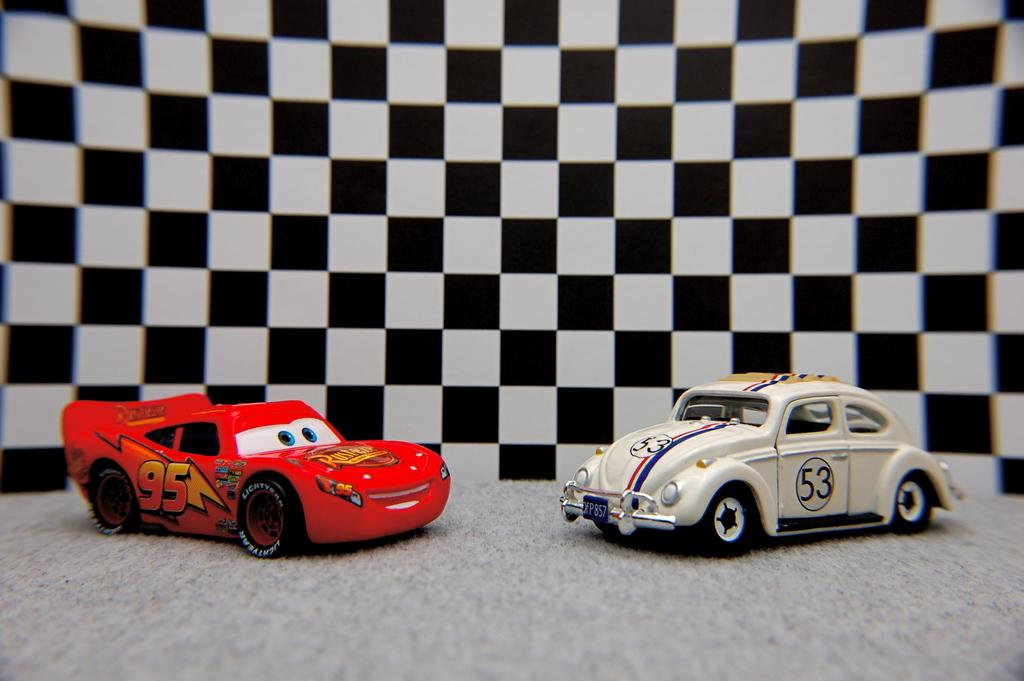What type of toys are present in the image? There are toy cars in the image. Can you describe the background of the image? There is a black and white check wall in the background of the image. How many eyes can be seen on the toy cars in the image? Toy cars do not have eyes, so this question cannot be answered based on the information provided. 